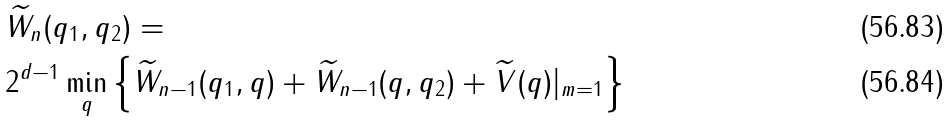<formula> <loc_0><loc_0><loc_500><loc_500>& \widetilde { W } _ { n } ( q _ { 1 } , q _ { 2 } ) = \\ & 2 ^ { d - 1 } \min _ { q } \left \{ \widetilde { W } _ { n - 1 } ( q _ { 1 } , q ) + \widetilde { W } _ { n - 1 } ( q , q _ { 2 } ) + \widetilde { V } ( q ) | _ { m = 1 } \right \}</formula> 